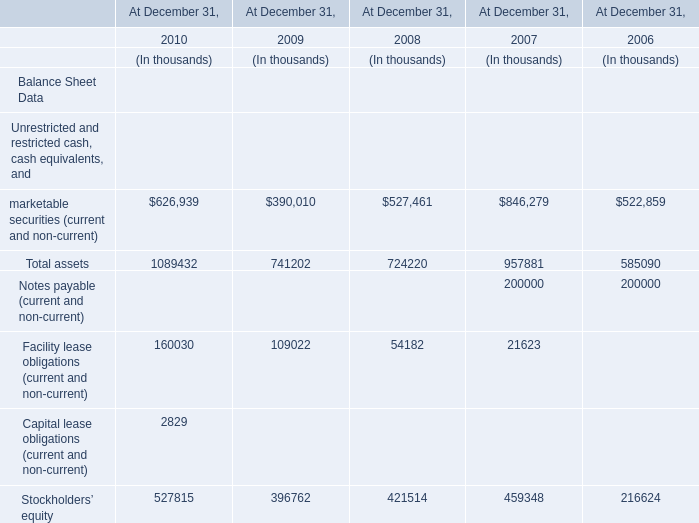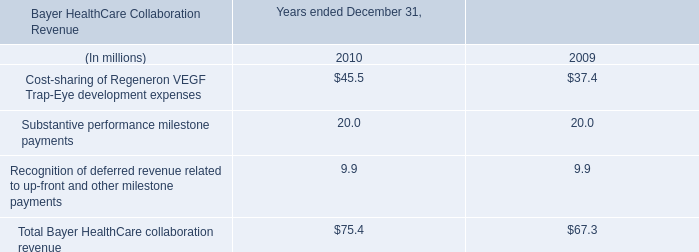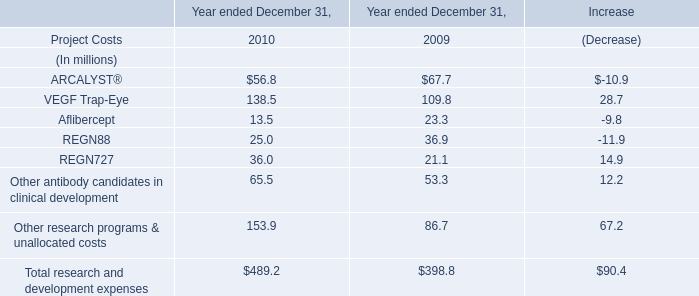what was the percentage change of total bayer healthcare collaboration revenue from 2009 to 2010? 
Computations: ((75.4 - 67.3) / 67.3)
Answer: 0.12036. In which year is the value of Total assets on December 31 the highest ? 
Answer: 2010. 